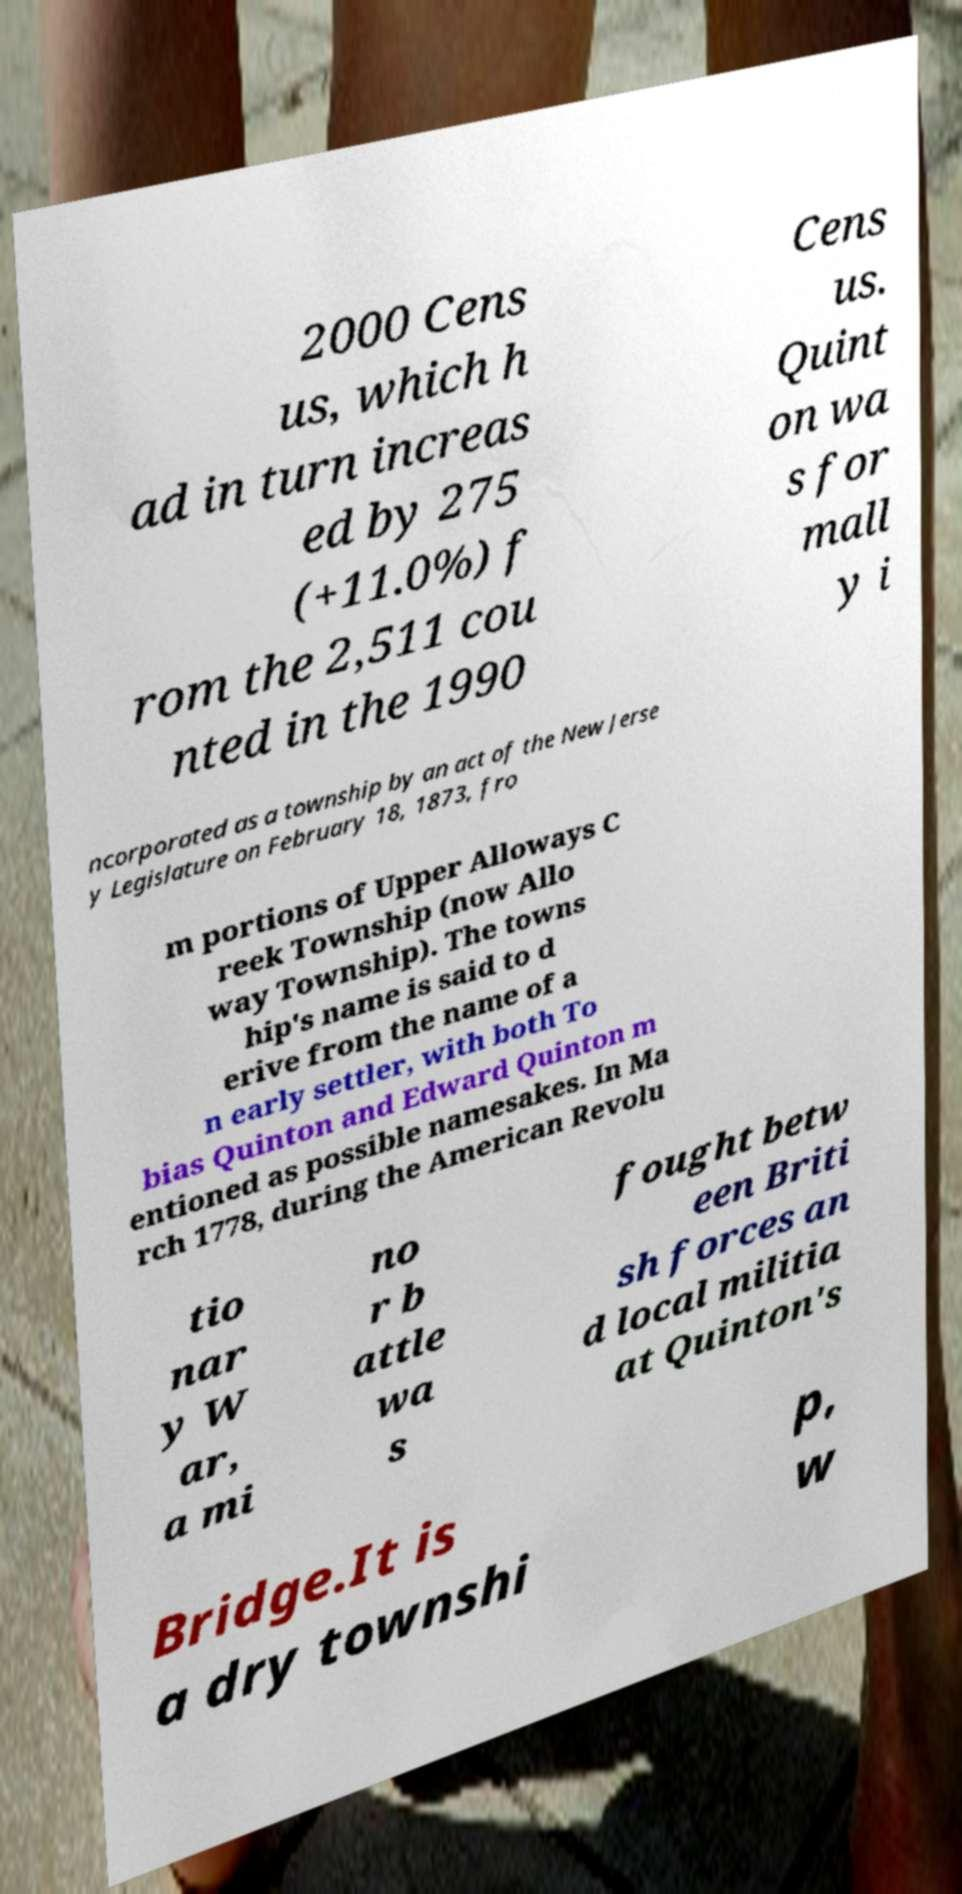There's text embedded in this image that I need extracted. Can you transcribe it verbatim? 2000 Cens us, which h ad in turn increas ed by 275 (+11.0%) f rom the 2,511 cou nted in the 1990 Cens us. Quint on wa s for mall y i ncorporated as a township by an act of the New Jerse y Legislature on February 18, 1873, fro m portions of Upper Alloways C reek Township (now Allo way Township). The towns hip's name is said to d erive from the name of a n early settler, with both To bias Quinton and Edward Quinton m entioned as possible namesakes. In Ma rch 1778, during the American Revolu tio nar y W ar, a mi no r b attle wa s fought betw een Briti sh forces an d local militia at Quinton's Bridge.It is a dry townshi p, w 